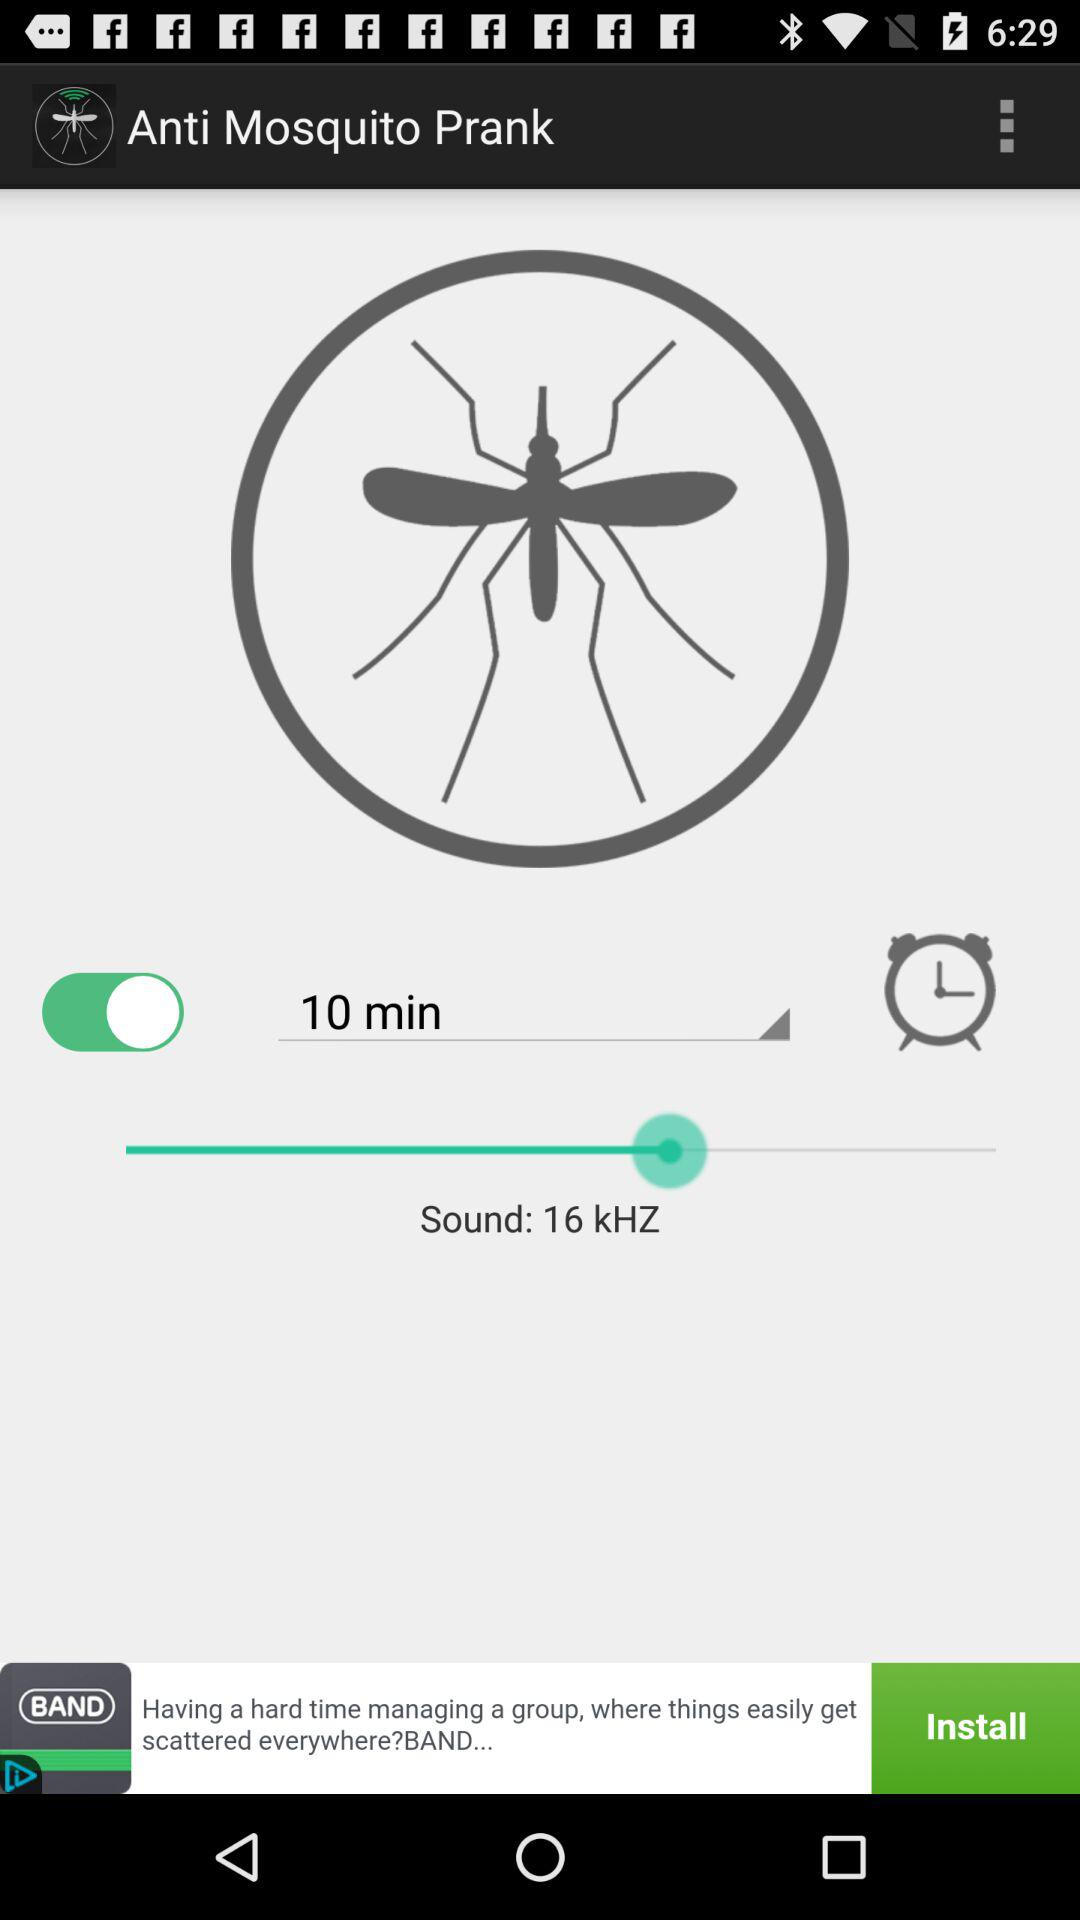What is the version of this application?
When the provided information is insufficient, respond with <no answer>. <no answer> 